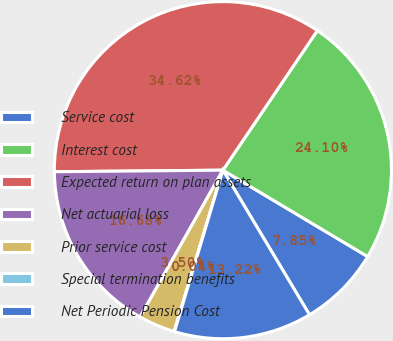<chart> <loc_0><loc_0><loc_500><loc_500><pie_chart><fcel>Service cost<fcel>Interest cost<fcel>Expected return on plan assets<fcel>Net actuarial loss<fcel>Prior service cost<fcel>Special termination benefits<fcel>Net Periodic Pension Cost<nl><fcel>7.85%<fcel>24.1%<fcel>34.62%<fcel>16.68%<fcel>3.5%<fcel>0.04%<fcel>13.22%<nl></chart> 